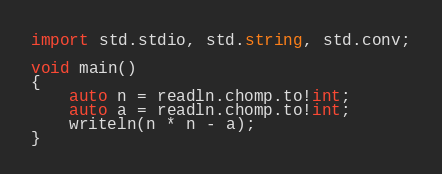<code> <loc_0><loc_0><loc_500><loc_500><_D_>import std.stdio, std.string, std.conv;

void main()
{
	auto n = readln.chomp.to!int;
	auto a = readln.chomp.to!int;
	writeln(n * n - a);
}</code> 